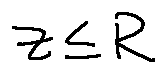<formula> <loc_0><loc_0><loc_500><loc_500>z \leq R</formula> 